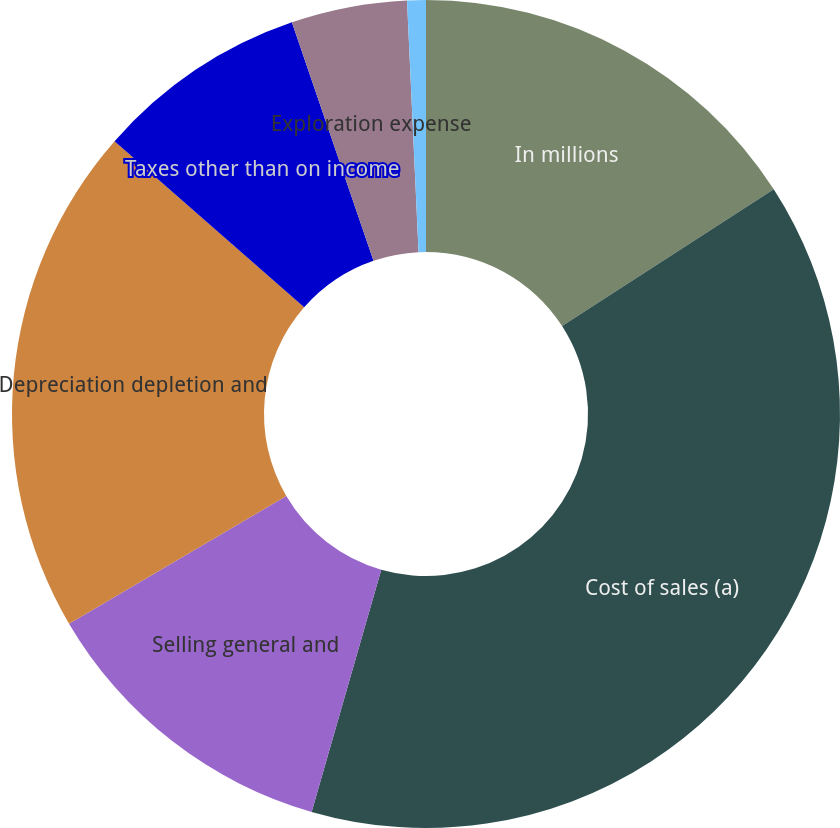<chart> <loc_0><loc_0><loc_500><loc_500><pie_chart><fcel>In millions<fcel>Cost of sales (a)<fcel>Selling general and<fcel>Depreciation depletion and<fcel>Taxes other than on income<fcel>Exploration expense<fcel>Interest and debt expense net<nl><fcel>15.87%<fcel>38.58%<fcel>12.09%<fcel>19.9%<fcel>8.3%<fcel>4.52%<fcel>0.73%<nl></chart> 